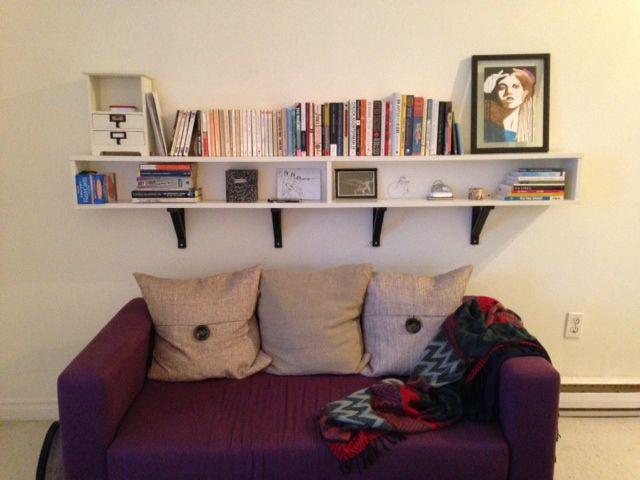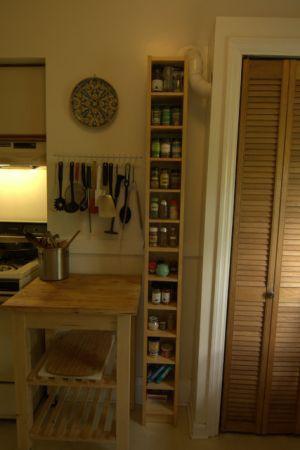The first image is the image on the left, the second image is the image on the right. For the images displayed, is the sentence "Left image shows a free-standing shelf divider featuring orange color." factually correct? Answer yes or no. No. The first image is the image on the left, the second image is the image on the right. Analyze the images presented: Is the assertion "In one image, tall, colorful open shelves, that are partly orange, are used as a room divider." valid? Answer yes or no. No. 